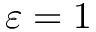Convert formula to latex. <formula><loc_0><loc_0><loc_500><loc_500>\varepsilon = 1</formula> 